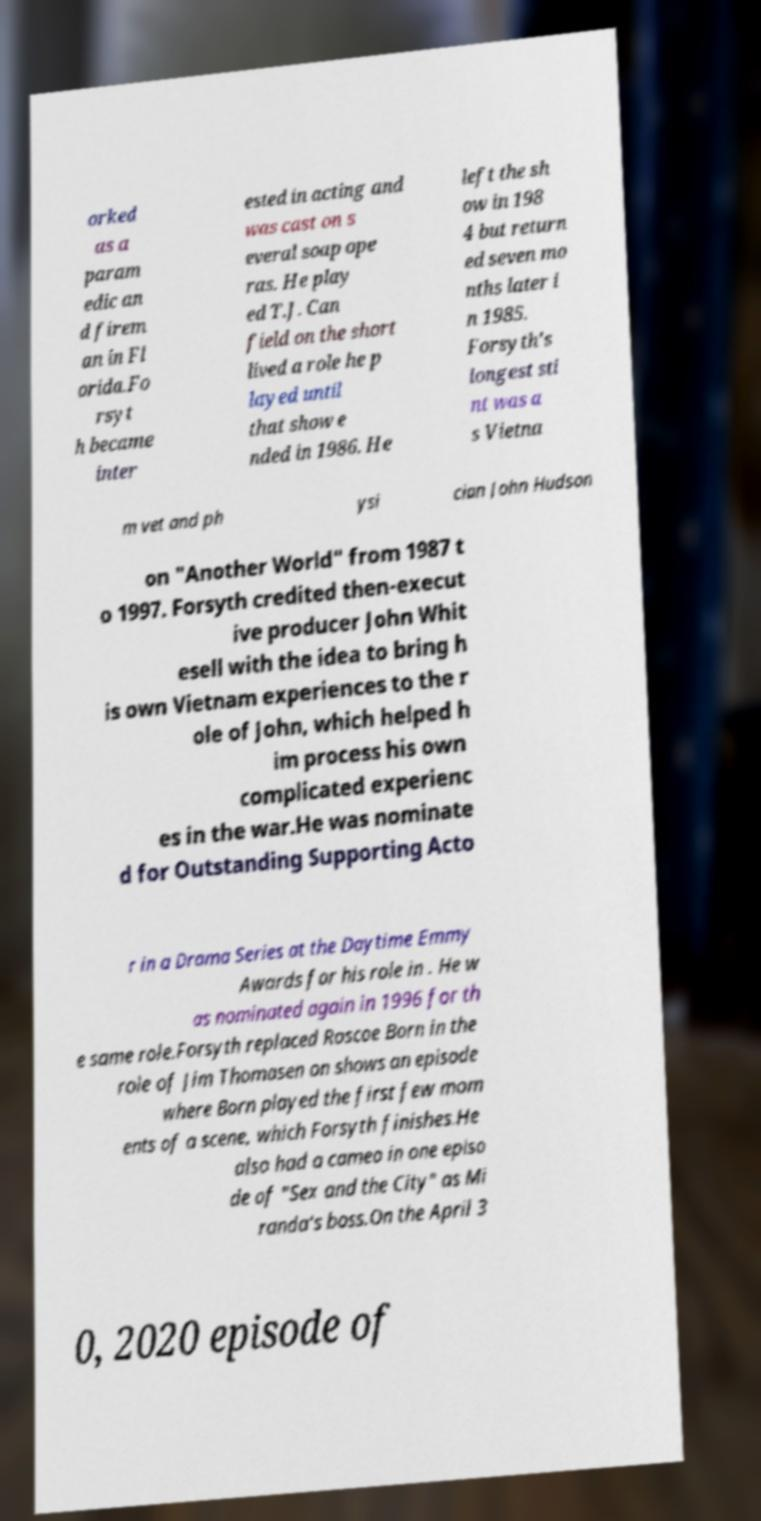Please identify and transcribe the text found in this image. orked as a param edic an d firem an in Fl orida.Fo rsyt h became inter ested in acting and was cast on s everal soap ope ras. He play ed T.J. Can field on the short lived a role he p layed until that show e nded in 1986. He left the sh ow in 198 4 but return ed seven mo nths later i n 1985. Forsyth's longest sti nt was a s Vietna m vet and ph ysi cian John Hudson on "Another World" from 1987 t o 1997. Forsyth credited then-execut ive producer John Whit esell with the idea to bring h is own Vietnam experiences to the r ole of John, which helped h im process his own complicated experienc es in the war.He was nominate d for Outstanding Supporting Acto r in a Drama Series at the Daytime Emmy Awards for his role in . He w as nominated again in 1996 for th e same role.Forsyth replaced Roscoe Born in the role of Jim Thomasen on shows an episode where Born played the first few mom ents of a scene, which Forsyth finishes.He also had a cameo in one episo de of "Sex and the City" as Mi randa's boss.On the April 3 0, 2020 episode of 